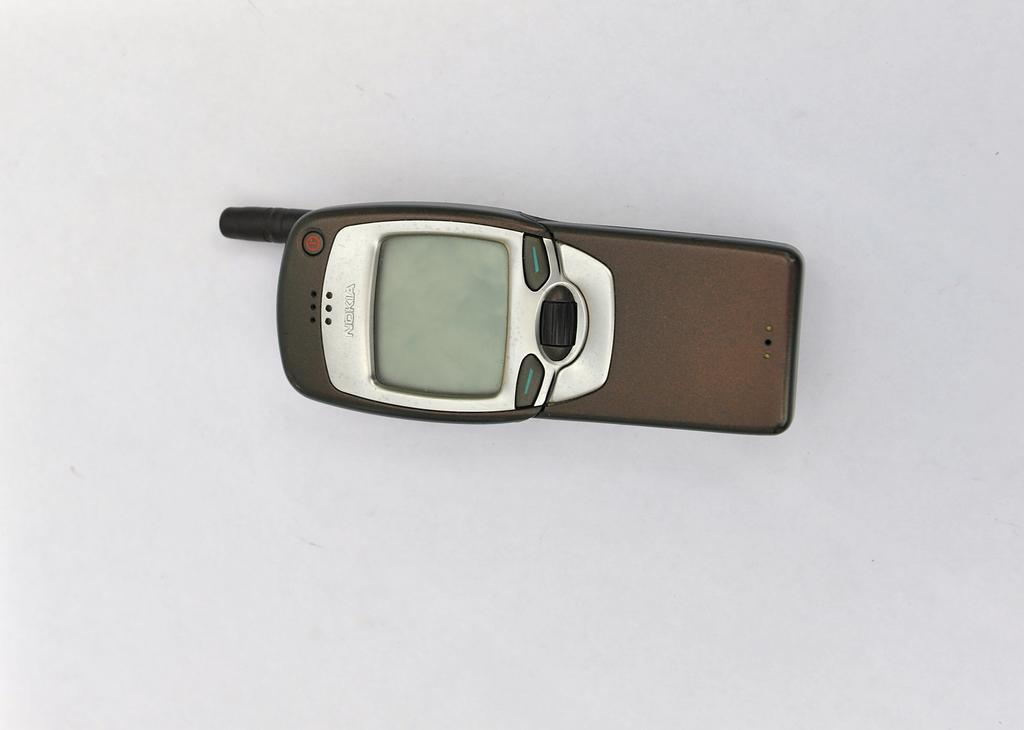<image>
Give a short and clear explanation of the subsequent image. A brown Nokia cell phone sits powered off. 